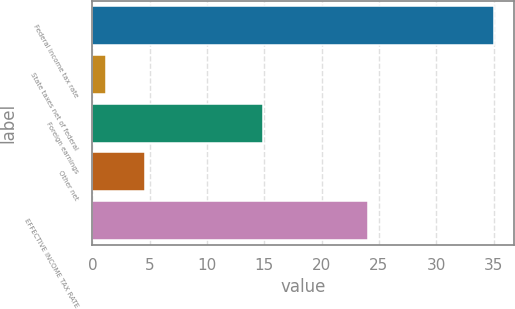Convert chart. <chart><loc_0><loc_0><loc_500><loc_500><bar_chart><fcel>Federal income tax rate<fcel>State taxes net of federal<fcel>Foreign earnings<fcel>Other net<fcel>EFFECTIVE INCOME TAX RATE<nl><fcel>35<fcel>1.2<fcel>14.9<fcel>4.58<fcel>24<nl></chart> 